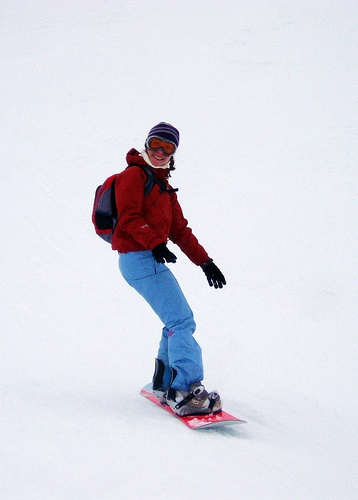Describe the objects in this image and their specific colors. I can see people in lavender, maroon, black, blue, and white tones, backpack in lavender, black, brown, navy, and maroon tones, and snowboard in lavender, darkgray, salmon, lightpink, and brown tones in this image. 